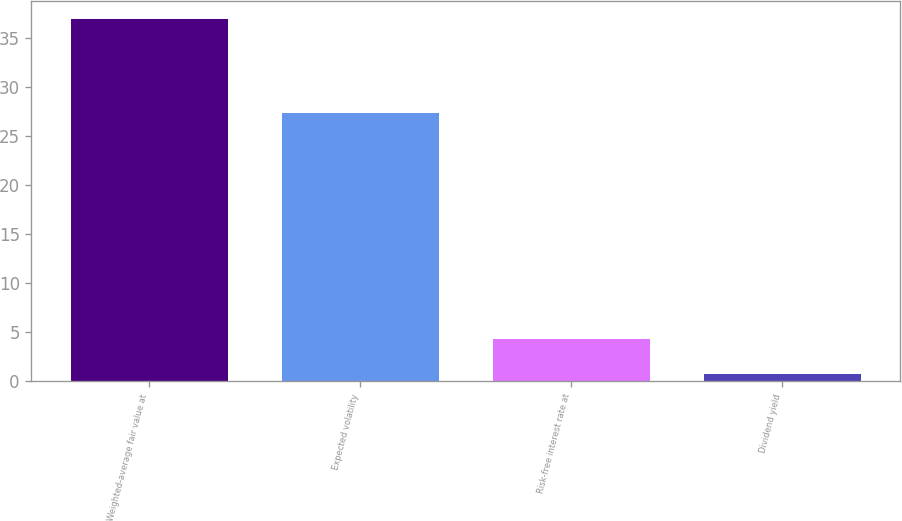<chart> <loc_0><loc_0><loc_500><loc_500><bar_chart><fcel>Weighted-average fair value at<fcel>Expected volatility<fcel>Risk-free interest rate at<fcel>Dividend yield<nl><fcel>36.91<fcel>27.4<fcel>4.32<fcel>0.7<nl></chart> 